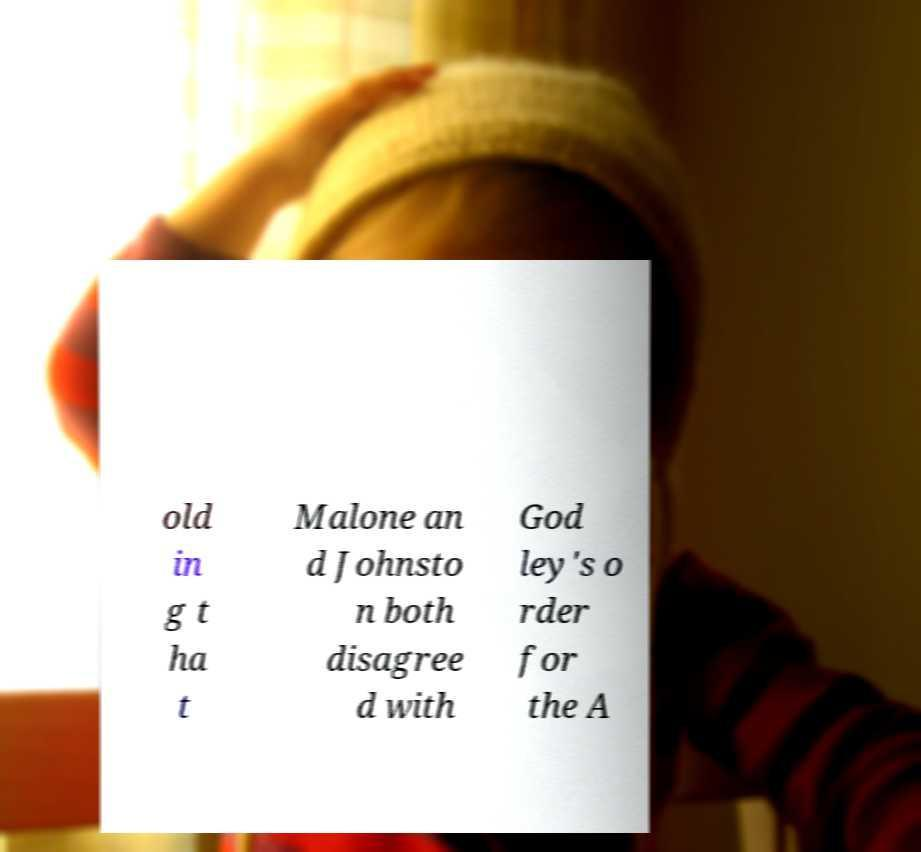There's text embedded in this image that I need extracted. Can you transcribe it verbatim? old in g t ha t Malone an d Johnsto n both disagree d with God ley's o rder for the A 